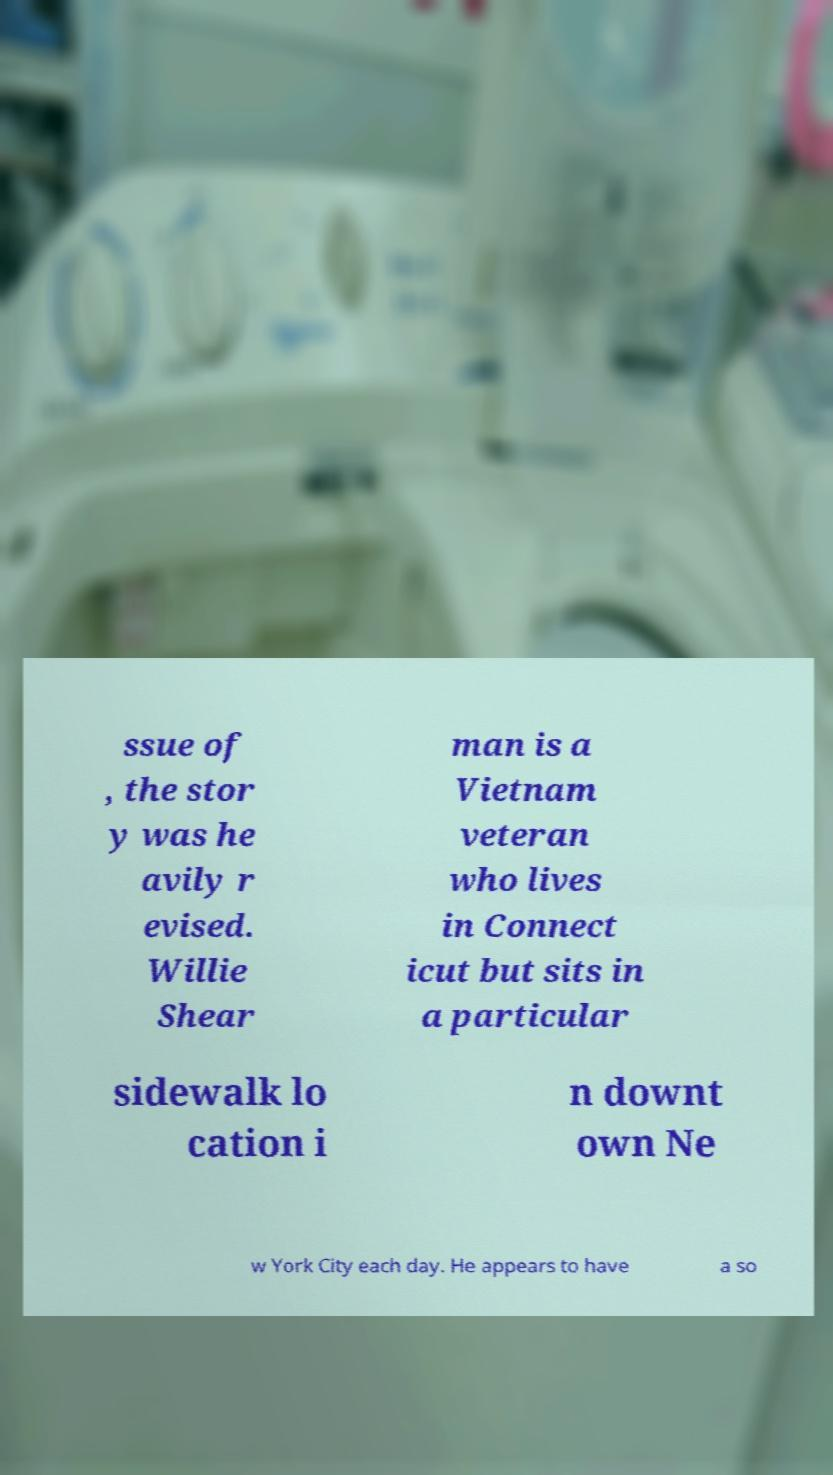Can you read and provide the text displayed in the image?This photo seems to have some interesting text. Can you extract and type it out for me? ssue of , the stor y was he avily r evised. Willie Shear man is a Vietnam veteran who lives in Connect icut but sits in a particular sidewalk lo cation i n downt own Ne w York City each day. He appears to have a so 